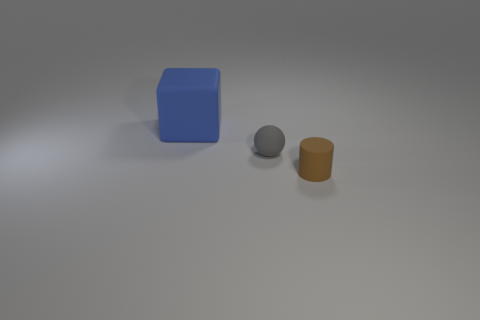Add 2 small yellow objects. How many objects exist? 5 Subtract all cubes. How many objects are left? 2 Subtract all tiny rubber spheres. Subtract all small brown matte cylinders. How many objects are left? 1 Add 2 rubber balls. How many rubber balls are left? 3 Add 1 blue rubber blocks. How many blue rubber blocks exist? 2 Subtract 1 gray balls. How many objects are left? 2 